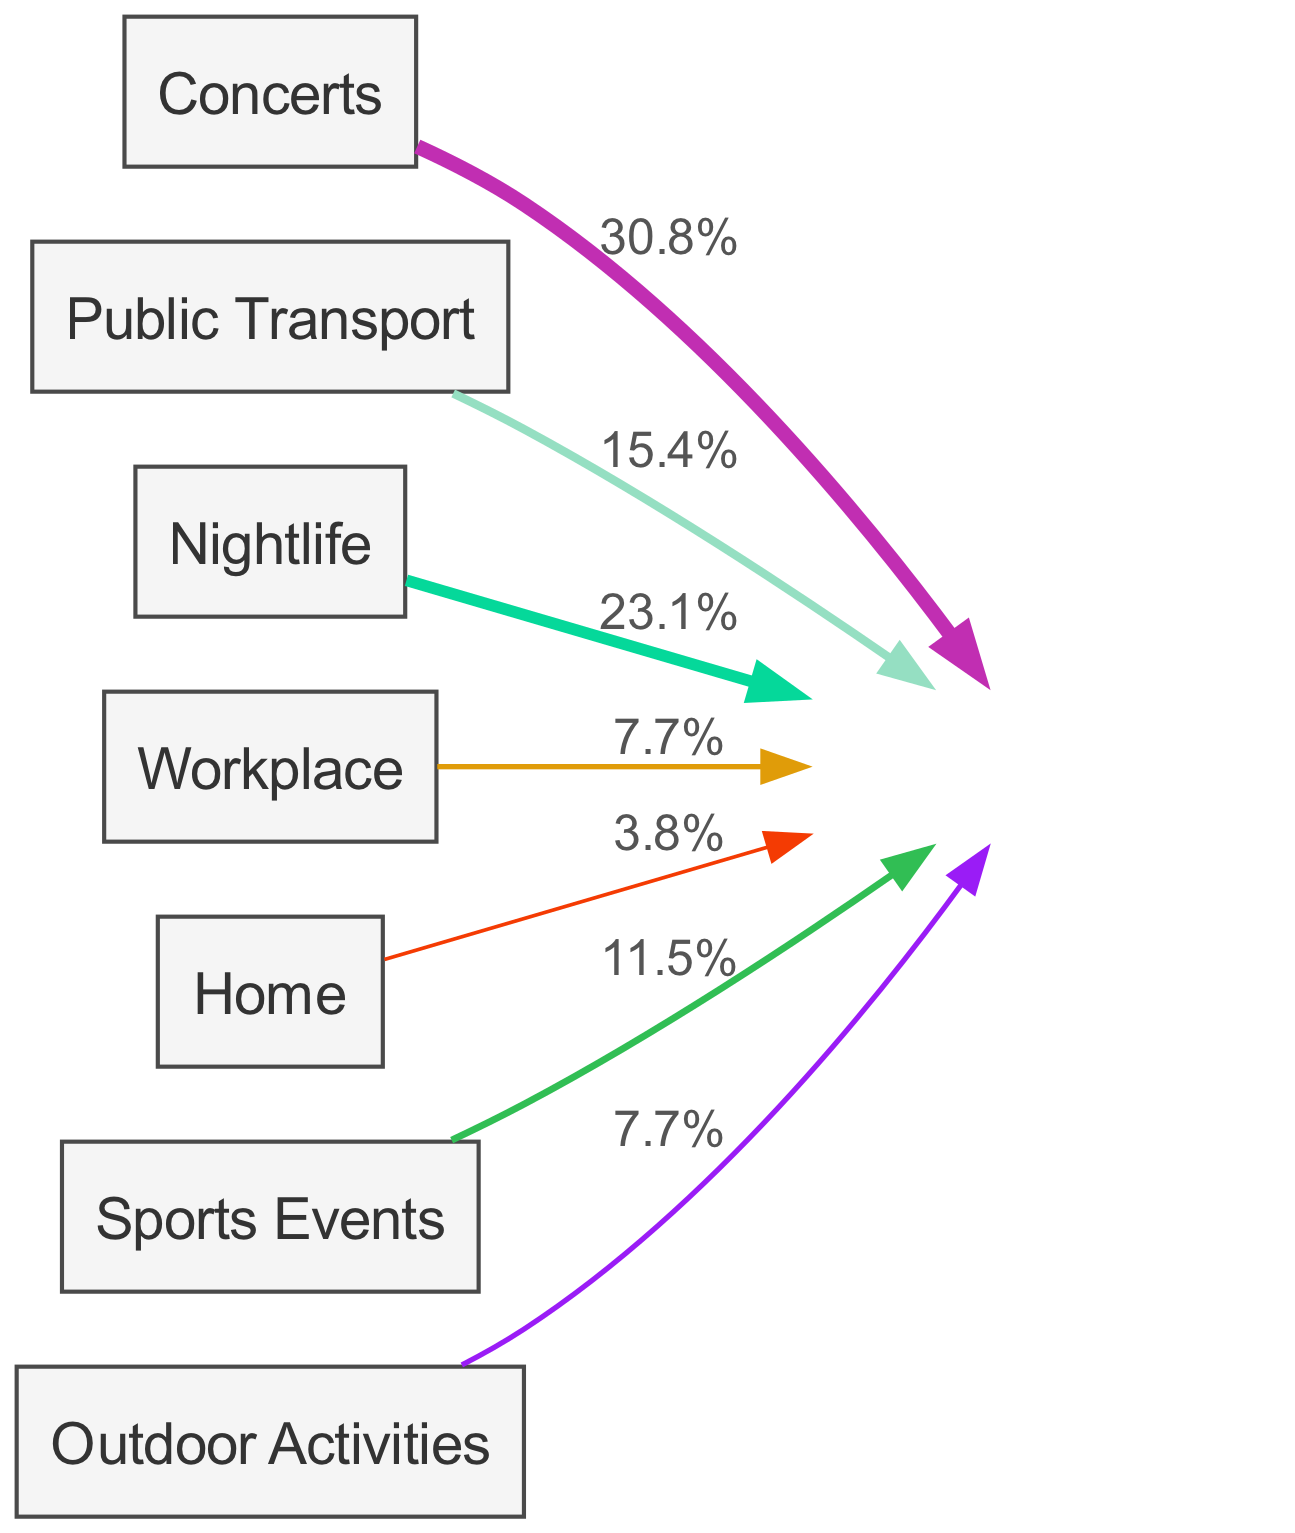what is the source with the highest noise exposure? By looking at the links in the diagram, "Concerts" has the highest value of 40, indicating the largest contribution to noise exposure.
Answer: Concerts how much noise exposure comes from Public Transport? The link from "Public Transport" to "Noise Exposure" shows a value of 20. This means that Public Transport contributes 20 to the total noise exposure.
Answer: 20 what is the total noise exposure value in the diagram? To find the total noise exposure, you sum all the values from the links: 40 (Concerts) + 20 (Public Transport) + 30 (Nightlife) + 10 (Workplace) + 5 (Home) + 15 (Sports Events) + 10 (Outdoor Activities) = 130.
Answer: 130 which source contributes more to noise exposure, Nightlife or Sports Events? Nightlife has a value of 30, while Sports Events has a value of 15. Comparing these values shows that Nightlife contributes more to noise exposure than Sports Events.
Answer: Nightlife how many sources of noise exposure are shown in the diagram? There are seven sources listed: Concerts, Public Transport, Nightlife, Workplace, Home, Sports Events, and Outdoor Activities, making a total of seven.
Answer: 7 what percentage of noise exposure comes from Home? The value from Home is 5. To find the percentage, calculate (5/130) * 100, which gives approximately 3.8%.
Answer: 3.8% which two sources combined contribute more than half of the noise exposure? Adding Concerts (40) and Nightlife (30) results in 70, which is greater than half of the total noise exposure (130). No other combination exceeds this.
Answer: Concerts and Nightlife what is the overall contribution from Workplace and Home together? Adding the values from Workplace (10) and Home (5) results in 15. This means together, they contribute a total of 15 to the noise exposure.
Answer: 15 what color represents the link from Outdoor Activities? Each link has a specific color based on a hash derived from the source. Calculating the color for Outdoor Activities using the provided scheme results in a particular color (which cannot be specified without rendering). So, the answer is that it has a unique color derived from its identifier.
Answer: unique color 